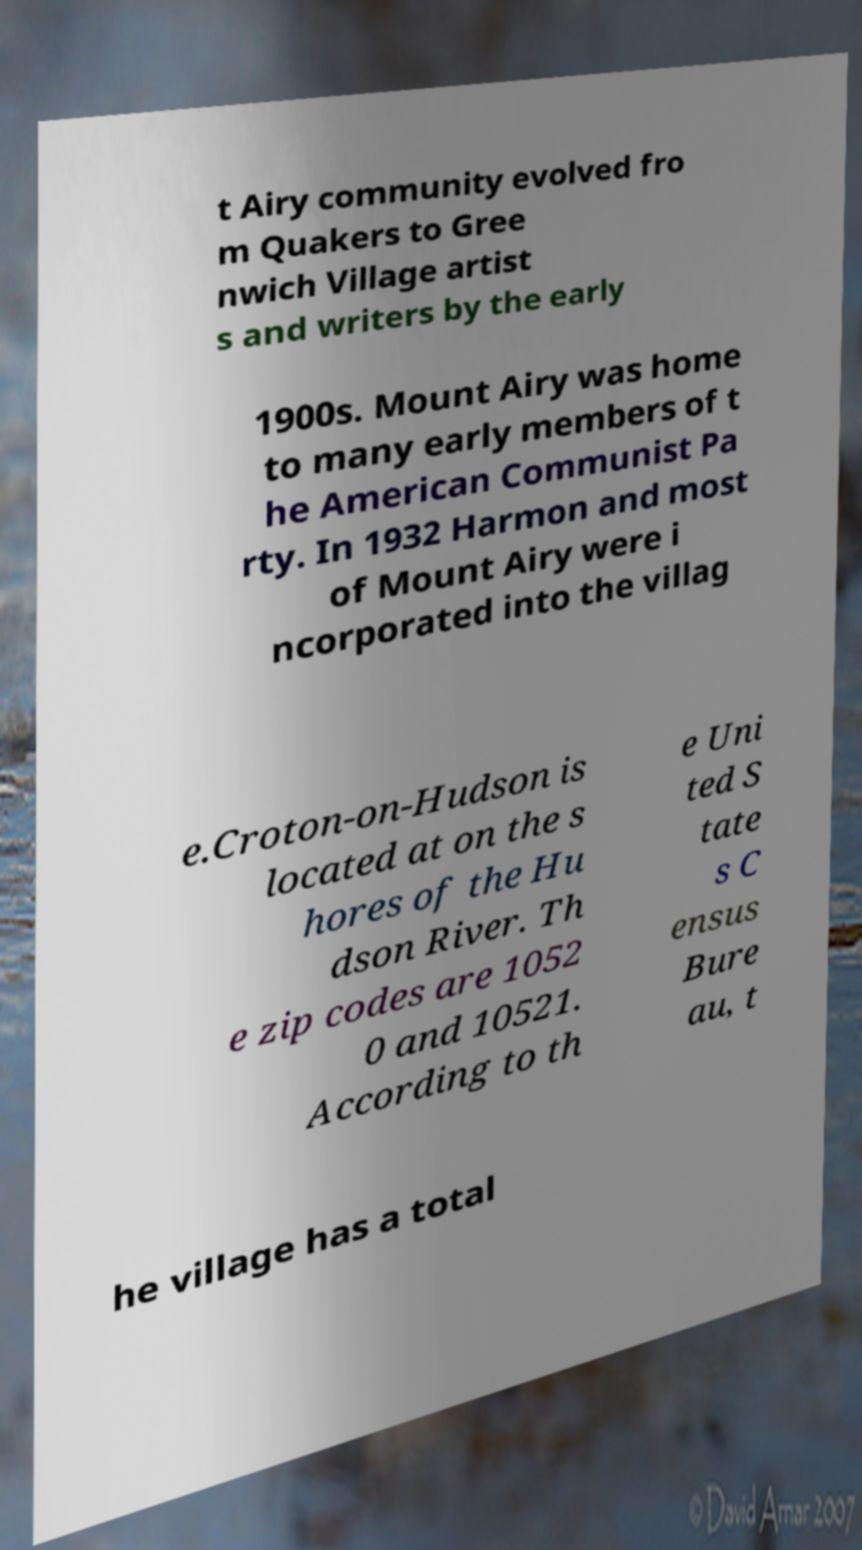What messages or text are displayed in this image? I need them in a readable, typed format. t Airy community evolved fro m Quakers to Gree nwich Village artist s and writers by the early 1900s. Mount Airy was home to many early members of t he American Communist Pa rty. In 1932 Harmon and most of Mount Airy were i ncorporated into the villag e.Croton-on-Hudson is located at on the s hores of the Hu dson River. Th e zip codes are 1052 0 and 10521. According to th e Uni ted S tate s C ensus Bure au, t he village has a total 